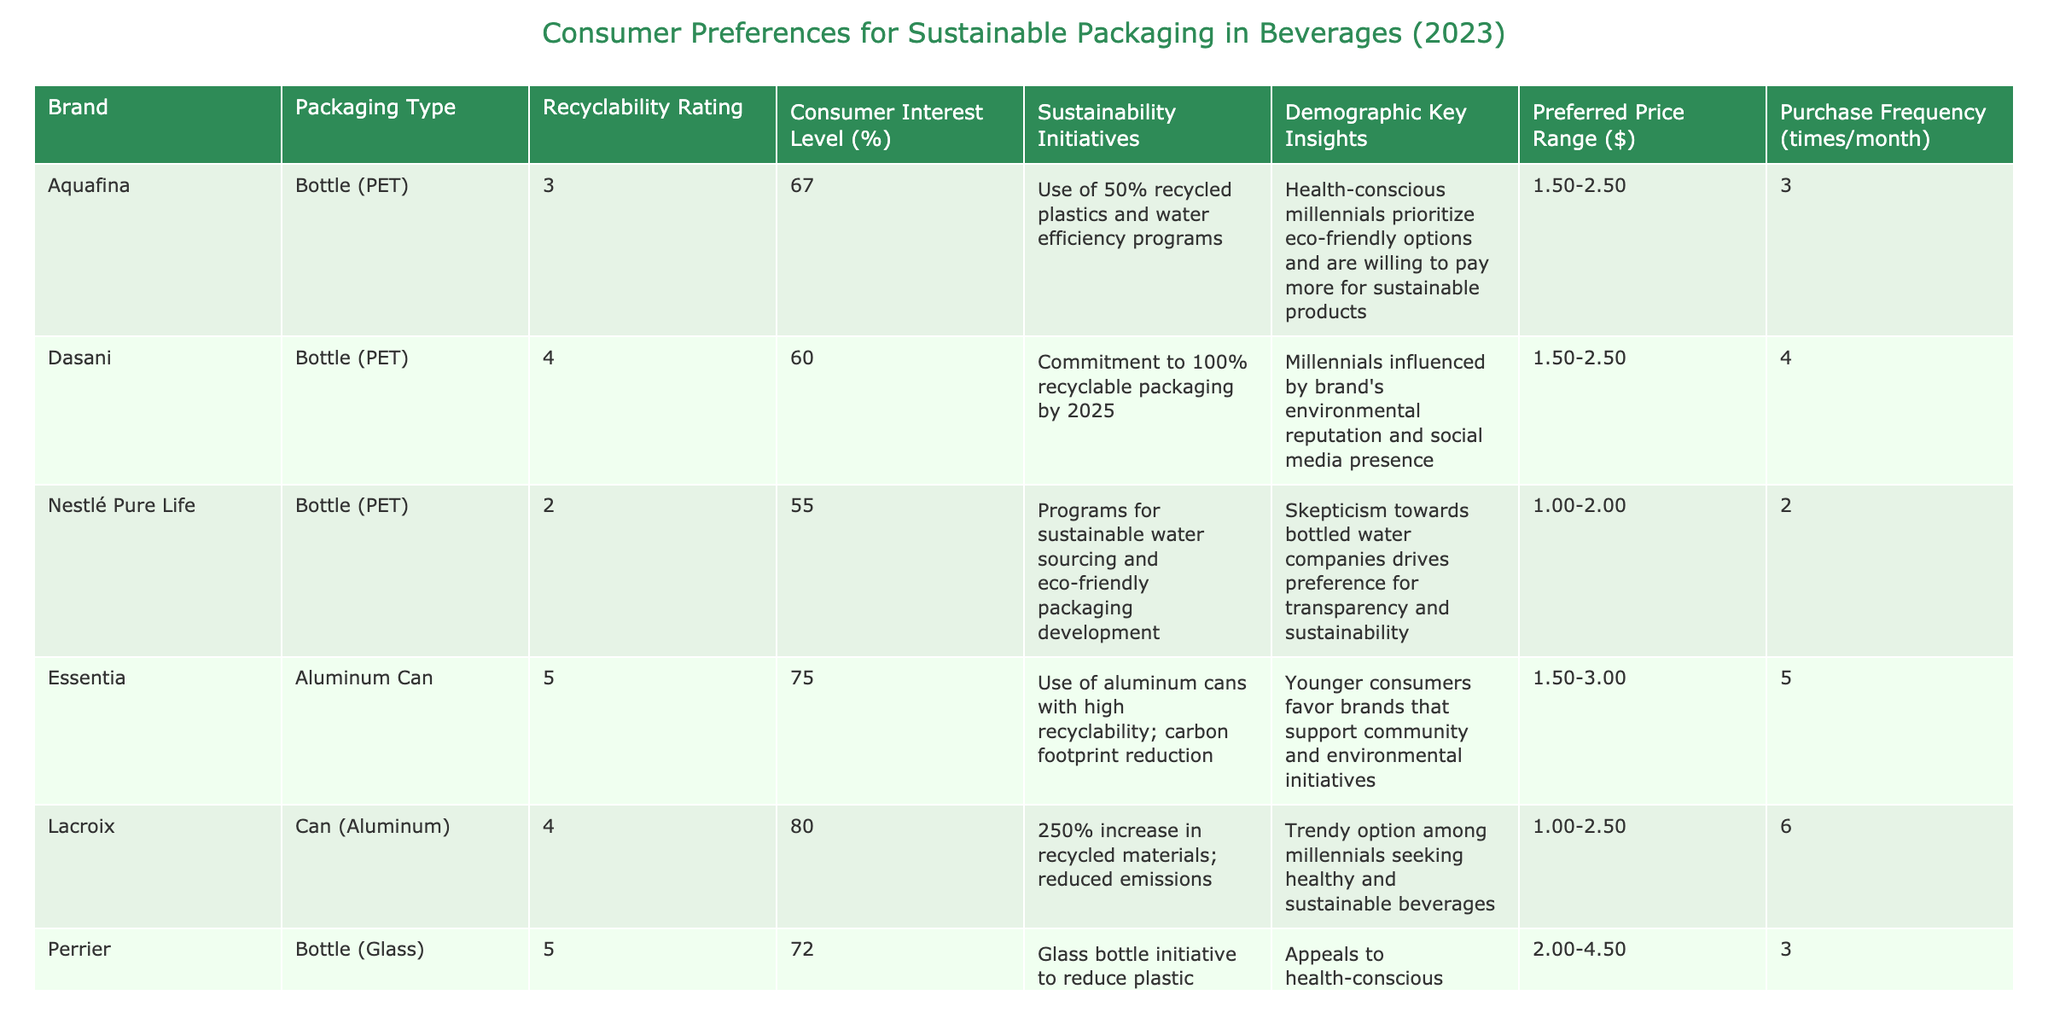What is the highest recyclability rating among the brands? The recyclability ratings are listed in the table; by scanning through the column, the highest rating is 5, which is found for the brands Essentia, Perrier, Honest Tea, and Martinelli's.
Answer: 5 Which brand has the lowest consumer interest level? The consumer interest levels can be found in the corresponding column. The lowest level is 55%, which corresponds to the brand Nestlé Pure Life.
Answer: Nestlé Pure Life What is the average purchase frequency for brands with a recyclability rating of 5? The purchase frequencies for brands with a rating of 5 are 5 (Essentia), 3 (Perrier), 2 (Martinelli's), and 6 (Honest Tea). The sum is 5 + 3 + 2 + 6 = 16, and there are 4 brands, so the average is 16 / 4 = 4.
Answer: 4 Is there any brand that has a preferred price range above $3.00? By looking at the preferred price ranges, the brands Martinelli's ($3.00 - $5.00) and Honest Tea ($2.00 - $3.50) have ranges that include values above $3.00. Therefore, at least one brand meets the criteria.
Answer: Yes Which packaging type has the highest average consumer interest level? The consumer interest levels for each packaging type are as follows: Bottle (PET) averages (67 + 60 + 55) / 3 = 60.67%; Aluminum Can averages (75 + 80) / 2 = 77.5%; Glass averages (72 + 68) / 2 = 70%. The Aluminum Can packaging type has the highest average interest level.
Answer: Aluminum Can Are health-conscious millennials more likely to prefer glass packaging based on the demographics listed? Looking at the descriptions, both Perrier and Honest Tea (glass packaging) appeal to health-conscious consumers. This suggests they may prefer glass packaging, supporting the claim.
Answer: Yes What brand has the highest recyclability rating that appeals to health-conscious millennials? Among the brands appealing to health-conscious millennials, both Perrier (rating 5) and Honest Tea (rating 5) fit the criteria. Therefore, both brands are the answer as they have the highest recyclability rating of 5.
Answer: Perrier and Honest Tea What is the total consumer interest level from the brands packaged in paper cartons? The only brand with paper carton packaging is Coconut Collaborative, which has a consumer interest level of 69%. Therefore, the total interest level from paper cartons is 69%.
Answer: 69 Which two brands have similar preferred price ranges but differ in their sustainability initiatives? Dashani and Aquafina both fall within the preferred price range of $1.50 - $2.50 but differ in their sustainability initiatives, with Aquafina focusing on 50% recycled plastics and Dasani committing to 100% recyclable packaging by 2025.
Answer: Dasani and Aquafina How many brands have a purchase frequency of 4 times or more per month? The brands with a purchase frequency of 4 or more per month are Dasani (4), Essentia (5), Lacroix (6), and Honest Tea (6), totaling 4 brands.
Answer: 4 